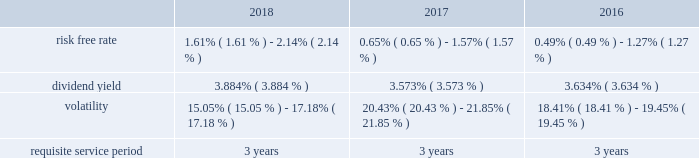Stock based compensation overview maa accounts for its stock based employee compensation plans in accordance with accounting standards governing stock based compensation .
These standards require an entity to measure the cost of employee services received in exchange for an award of an equity instrument based on the award's fair value on the grant date and recognize the cost over the period during which the employee is required to provide service in exchange for the award , which is generally the vesting period .
Any liability awards issued are remeasured at each reporting period .
Maa 2019s stock compensation plans consist of a number of incentives provided to attract and retain independent directors , executive officers and key employees .
Incentives are currently granted under the second amended and restated 2013 stock incentive plan , or the stock plan , which was approved at the 2018 annual meeting of maa shareholders .
The stock plan allows for the grant of restricted stock and stock options up to 2000000 shares .
Maa believes that such awards better align the interests of its employees with those of its shareholders .
Compensation expense is generally recognized for service based restricted stock awards using the straight-line method over the vesting period of the shares regardless of cliff or ratable vesting distinctions .
Compensation expense for market and performance based restricted stock awards is generally recognized using the accelerated amortization method with each vesting tranche valued as a separate award , with a separate vesting date , consistent with the estimated value of the award at each period end .
Additionally , compensation expense is adjusted for actual forfeitures for all awards in the period that the award was forfeited .
Compensation expense for stock options is generally recognized on a straight-line basis over the requisite service period .
Maa presents stock compensation expense in the consolidated statements of operations in "general and administrative expenses" .
Total compensation expense under the stock plan was $ 12.9 million , $ 10.8 million and $ 12.2 million for the years ended december 31 , 2018 , 2017 and 2016 , respectively .
Of these amounts , total compensation expense capitalized was $ 0.5 million , $ 0.2 million and $ 0.7 million for the years ended december 31 , 2018 , 2017 and 2016 , respectively .
As of december 31 , 2018 , the total unrecognized compensation expense was $ 13.5 million .
This cost is expected to be recognized over the remaining weighted average period of 1.1 years .
Total cash paid for the settlement of plan shares totaled $ 2.9 million , $ 4.8 million and $ 2.0 million for the years ended december 31 , 2018 , 2017 and 2016 , respectively .
Information concerning grants under the stock plan is provided below .
Restricted stock in general , restricted stock is earned based on either a service condition , performance condition , or market condition , or a combination thereof , and generally vests ratably over a period from 1 year to 5 years .
Service based awards are earned when the employee remains employed over the requisite service period and are valued on the grant date based upon the market price of maa common stock on the date of grant .
Market based awards are earned when maa reaches a specified stock price or specified return on the stock price ( price appreciation plus dividends ) and are valued on the grant date using a monte carlo simulation .
Performance based awards are earned when maa reaches certain operational goals such as funds from operations , or ffo , targets and are valued based upon the market price of maa common stock on the date of grant as well as the probability of reaching the stated targets .
Maa remeasures the fair value of the performance based awards each balance sheet date with adjustments made on a cumulative basis until the award is settled and the final compensation is known .
The weighted average grant date fair value per share of restricted stock awards granted during the years ended december 31 , 2018 , 2017 and 2016 , was $ 71.85 , $ 84.53 and $ 73.20 , respectively .
The following is a summary of the key assumptions used in the valuation calculations for market based awards granted during the years ended december 31 , 2018 , 2017 and 2016: .
The risk free rate was based on a zero coupon risk-free rate .
The minimum risk free rate was based on a period of 0.25 years for the years ended december 31 , 2018 , 2017 and 2016 .
The maximum risk free rate was based on a period of 3 years for the years ended december 31 , 2018 , 2017 and 2016 .
The dividend yield was based on the closing stock price of maa stock on the .
What is the highest dividend yield during 2016-2018? 
Rationale: it is the maximum value for the dividend yield during this period .
Computations: table_max(dividend yield, none)
Answer: 0.03884. Stock based compensation overview maa accounts for its stock based employee compensation plans in accordance with accounting standards governing stock based compensation .
These standards require an entity to measure the cost of employee services received in exchange for an award of an equity instrument based on the award's fair value on the grant date and recognize the cost over the period during which the employee is required to provide service in exchange for the award , which is generally the vesting period .
Any liability awards issued are remeasured at each reporting period .
Maa 2019s stock compensation plans consist of a number of incentives provided to attract and retain independent directors , executive officers and key employees .
Incentives are currently granted under the second amended and restated 2013 stock incentive plan , or the stock plan , which was approved at the 2018 annual meeting of maa shareholders .
The stock plan allows for the grant of restricted stock and stock options up to 2000000 shares .
Maa believes that such awards better align the interests of its employees with those of its shareholders .
Compensation expense is generally recognized for service based restricted stock awards using the straight-line method over the vesting period of the shares regardless of cliff or ratable vesting distinctions .
Compensation expense for market and performance based restricted stock awards is generally recognized using the accelerated amortization method with each vesting tranche valued as a separate award , with a separate vesting date , consistent with the estimated value of the award at each period end .
Additionally , compensation expense is adjusted for actual forfeitures for all awards in the period that the award was forfeited .
Compensation expense for stock options is generally recognized on a straight-line basis over the requisite service period .
Maa presents stock compensation expense in the consolidated statements of operations in "general and administrative expenses" .
Total compensation expense under the stock plan was $ 12.9 million , $ 10.8 million and $ 12.2 million for the years ended december 31 , 2018 , 2017 and 2016 , respectively .
Of these amounts , total compensation expense capitalized was $ 0.5 million , $ 0.2 million and $ 0.7 million for the years ended december 31 , 2018 , 2017 and 2016 , respectively .
As of december 31 , 2018 , the total unrecognized compensation expense was $ 13.5 million .
This cost is expected to be recognized over the remaining weighted average period of 1.1 years .
Total cash paid for the settlement of plan shares totaled $ 2.9 million , $ 4.8 million and $ 2.0 million for the years ended december 31 , 2018 , 2017 and 2016 , respectively .
Information concerning grants under the stock plan is provided below .
Restricted stock in general , restricted stock is earned based on either a service condition , performance condition , or market condition , or a combination thereof , and generally vests ratably over a period from 1 year to 5 years .
Service based awards are earned when the employee remains employed over the requisite service period and are valued on the grant date based upon the market price of maa common stock on the date of grant .
Market based awards are earned when maa reaches a specified stock price or specified return on the stock price ( price appreciation plus dividends ) and are valued on the grant date using a monte carlo simulation .
Performance based awards are earned when maa reaches certain operational goals such as funds from operations , or ffo , targets and are valued based upon the market price of maa common stock on the date of grant as well as the probability of reaching the stated targets .
Maa remeasures the fair value of the performance based awards each balance sheet date with adjustments made on a cumulative basis until the award is settled and the final compensation is known .
The weighted average grant date fair value per share of restricted stock awards granted during the years ended december 31 , 2018 , 2017 and 2016 , was $ 71.85 , $ 84.53 and $ 73.20 , respectively .
The following is a summary of the key assumptions used in the valuation calculations for market based awards granted during the years ended december 31 , 2018 , 2017 and 2016: .
The risk free rate was based on a zero coupon risk-free rate .
The minimum risk free rate was based on a period of 0.25 years for the years ended december 31 , 2018 , 2017 and 2016 .
The maximum risk free rate was based on a period of 3 years for the years ended december 31 , 2018 , 2017 and 2016 .
The dividend yield was based on the closing stock price of maa stock on the .
What was the percent of the change in the in the dividend yield from 2017 to 2018? 
Rationale: the dividend yield increased by 8.7% from 2017 to 2018
Computations: ((3.884 - 3.573) / 3.573)
Answer: 0.08704. 